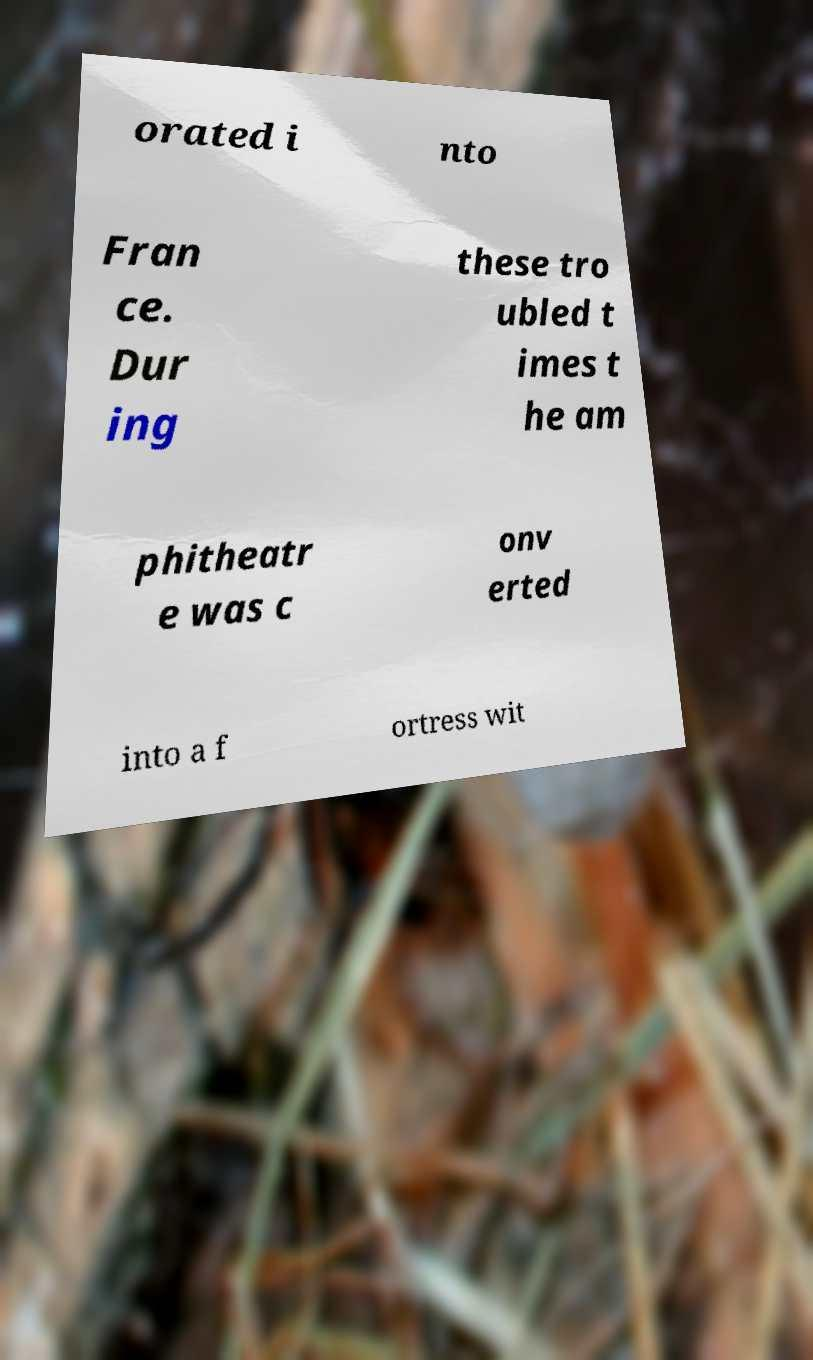Could you extract and type out the text from this image? orated i nto Fran ce. Dur ing these tro ubled t imes t he am phitheatr e was c onv erted into a f ortress wit 